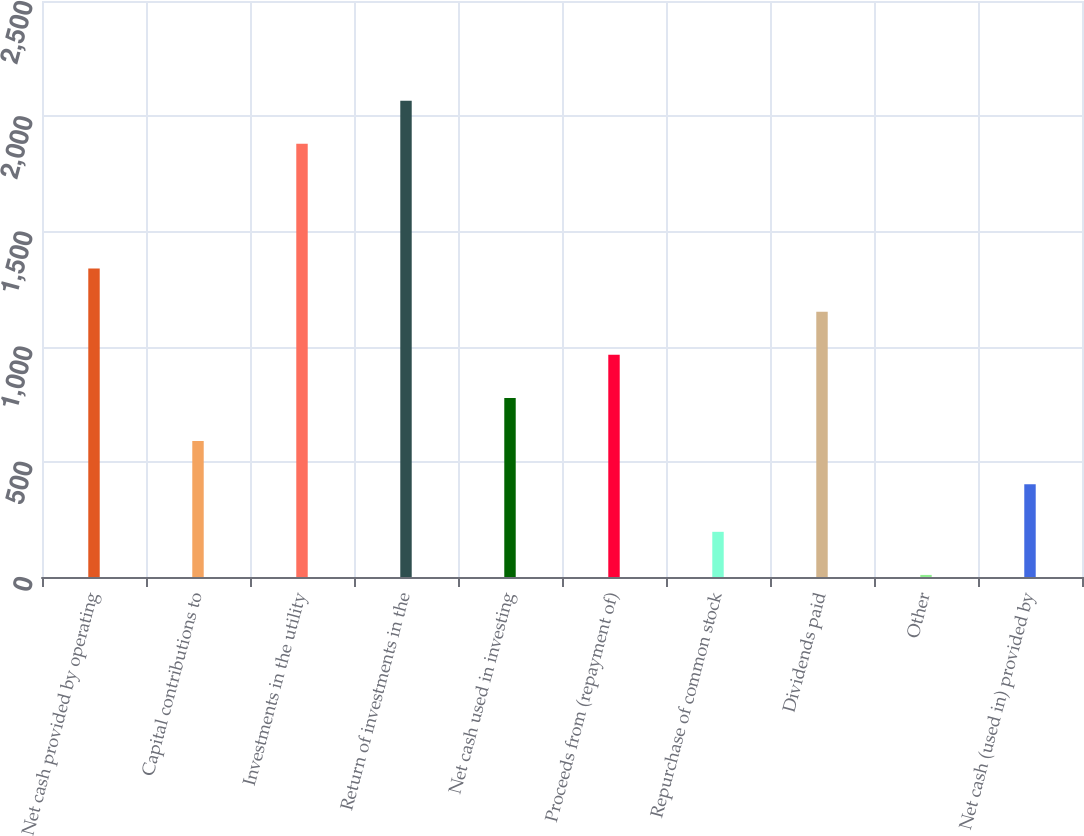Convert chart. <chart><loc_0><loc_0><loc_500><loc_500><bar_chart><fcel>Net cash provided by operating<fcel>Capital contributions to<fcel>Investments in the utility<fcel>Return of investments in the<fcel>Net cash used in investing<fcel>Proceeds from (repayment of)<fcel>Repurchase of common stock<fcel>Dividends paid<fcel>Other<fcel>Net cash (used in) provided by<nl><fcel>1338.5<fcel>590.1<fcel>1880<fcel>2067.1<fcel>777.2<fcel>964.3<fcel>196.1<fcel>1151.4<fcel>9<fcel>403<nl></chart> 